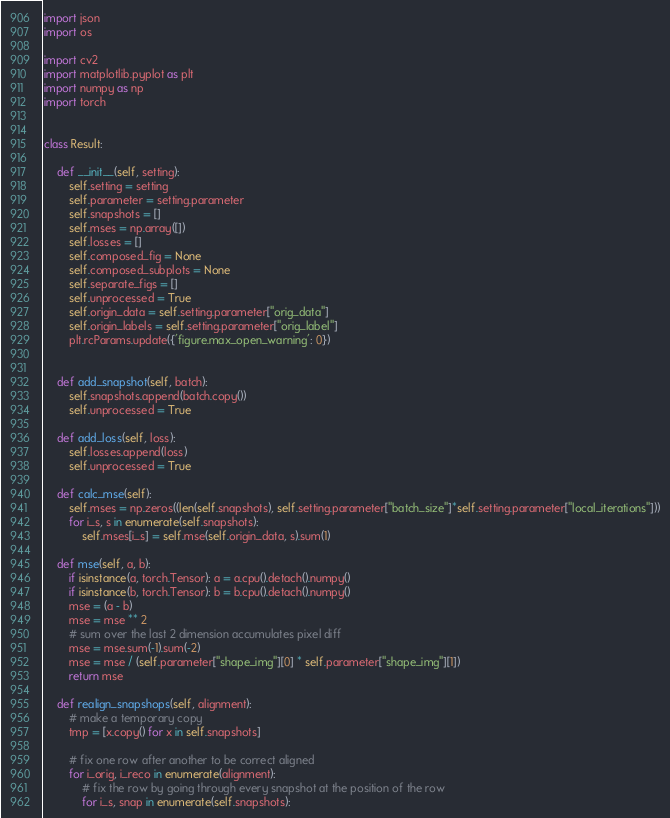<code> <loc_0><loc_0><loc_500><loc_500><_Python_>import json
import os

import cv2
import matplotlib.pyplot as plt
import numpy as np
import torch


class Result:

    def __init__(self, setting):
        self.setting = setting
        self.parameter = setting.parameter
        self.snapshots = []
        self.mses = np.array([])
        self.losses = []
        self.composed_fig = None
        self.composed_subplots = None
        self.separate_figs = []
        self.unprocessed = True
        self.origin_data = self.setting.parameter["orig_data"]
        self.origin_labels = self.setting.parameter["orig_label"]
        plt.rcParams.update({'figure.max_open_warning': 0})


    def add_snapshot(self, batch):
        self.snapshots.append(batch.copy())
        self.unprocessed = True

    def add_loss(self, loss):
        self.losses.append(loss)
        self.unprocessed = True

    def calc_mse(self):
        self.mses = np.zeros((len(self.snapshots), self.setting.parameter["batch_size"]*self.setting.parameter["local_iterations"]))
        for i_s, s in enumerate(self.snapshots):
            self.mses[i_s] = self.mse(self.origin_data, s).sum(1)

    def mse(self, a, b):
        if isinstance(a, torch.Tensor): a = a.cpu().detach().numpy()
        if isinstance(b, torch.Tensor): b = b.cpu().detach().numpy()
        mse = (a - b)
        mse = mse ** 2
        # sum over the last 2 dimension accumulates pixel diff
        mse = mse.sum(-1).sum(-2)
        mse = mse / (self.parameter["shape_img"][0] * self.parameter["shape_img"][1])
        return mse

    def realign_snapshops(self, alignment):
        # make a temporary copy
        tmp = [x.copy() for x in self.snapshots]

        # fix one row after another to be correct aligned
        for i_orig, i_reco in enumerate(alignment):
            # fix the row by going through every snapshot at the position of the row
            for i_s, snap in enumerate(self.snapshots):</code> 